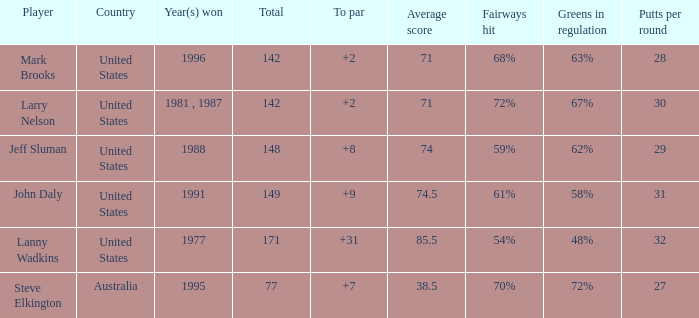Name the Total of jeff sluman? 148.0. 